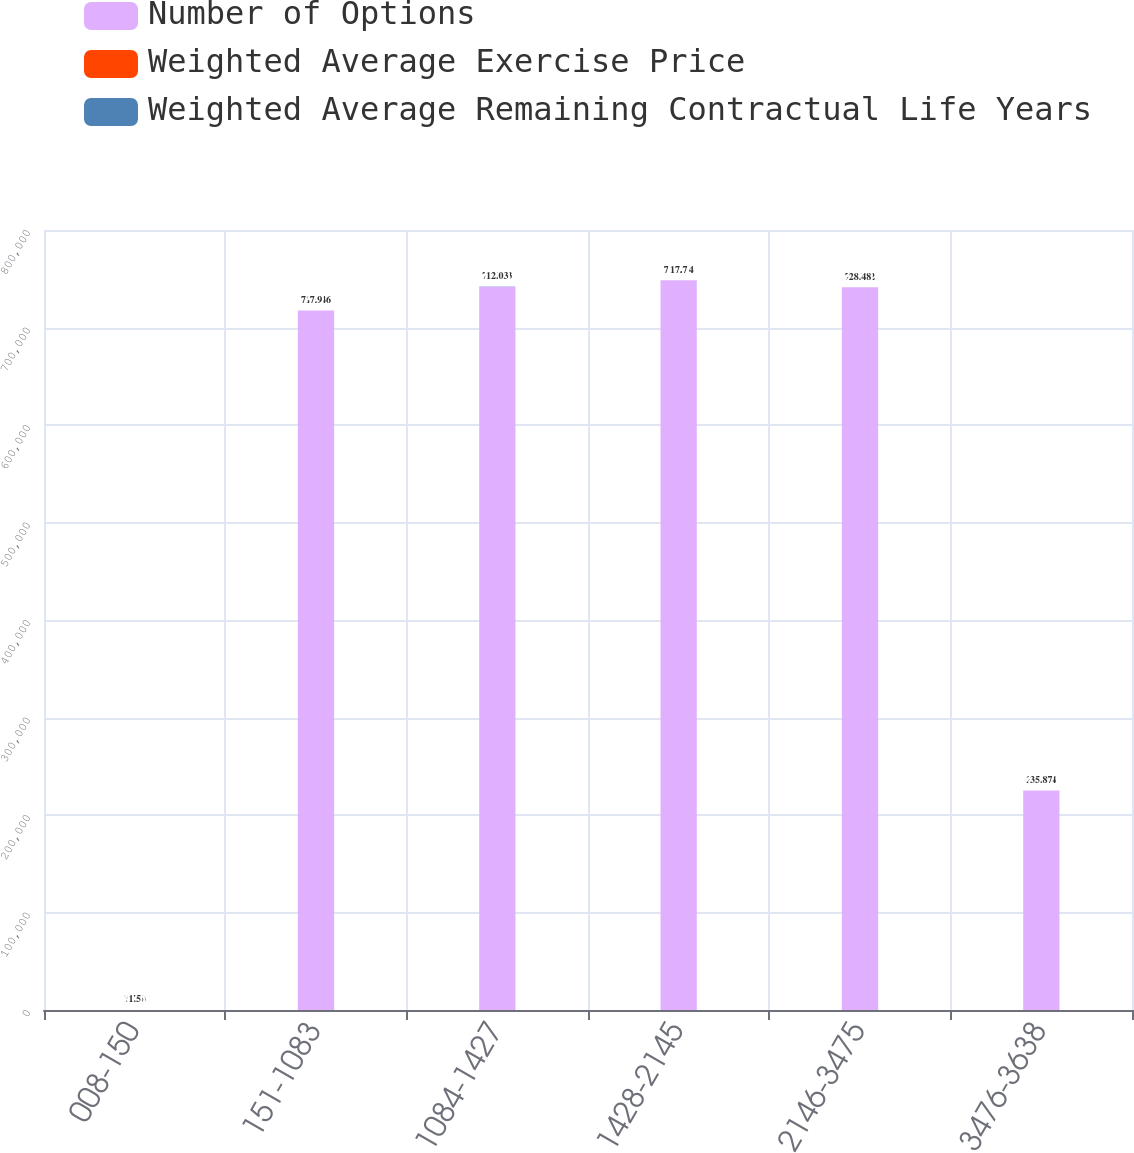Convert chart to OTSL. <chart><loc_0><loc_0><loc_500><loc_500><stacked_bar_chart><ecel><fcel>008-150<fcel>151-1083<fcel>1084-1427<fcel>1428-2145<fcel>2146-3475<fcel>3476-3638<nl><fcel>Number of Options<fcel>12.03<fcel>717346<fcel>741913<fcel>748434<fcel>741232<fcel>225064<nl><fcel>Weighted Average Exercise Price<fcel>5.76<fcel>8<fcel>8.77<fcel>9.05<fcel>8.7<fcel>8.25<nl><fcel>Weighted Average Remaining Contractual Life Years<fcel>1.5<fcel>7.9<fcel>12.03<fcel>17.7<fcel>28.48<fcel>35.87<nl></chart> 